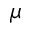Convert formula to latex. <formula><loc_0><loc_0><loc_500><loc_500>\mu</formula> 